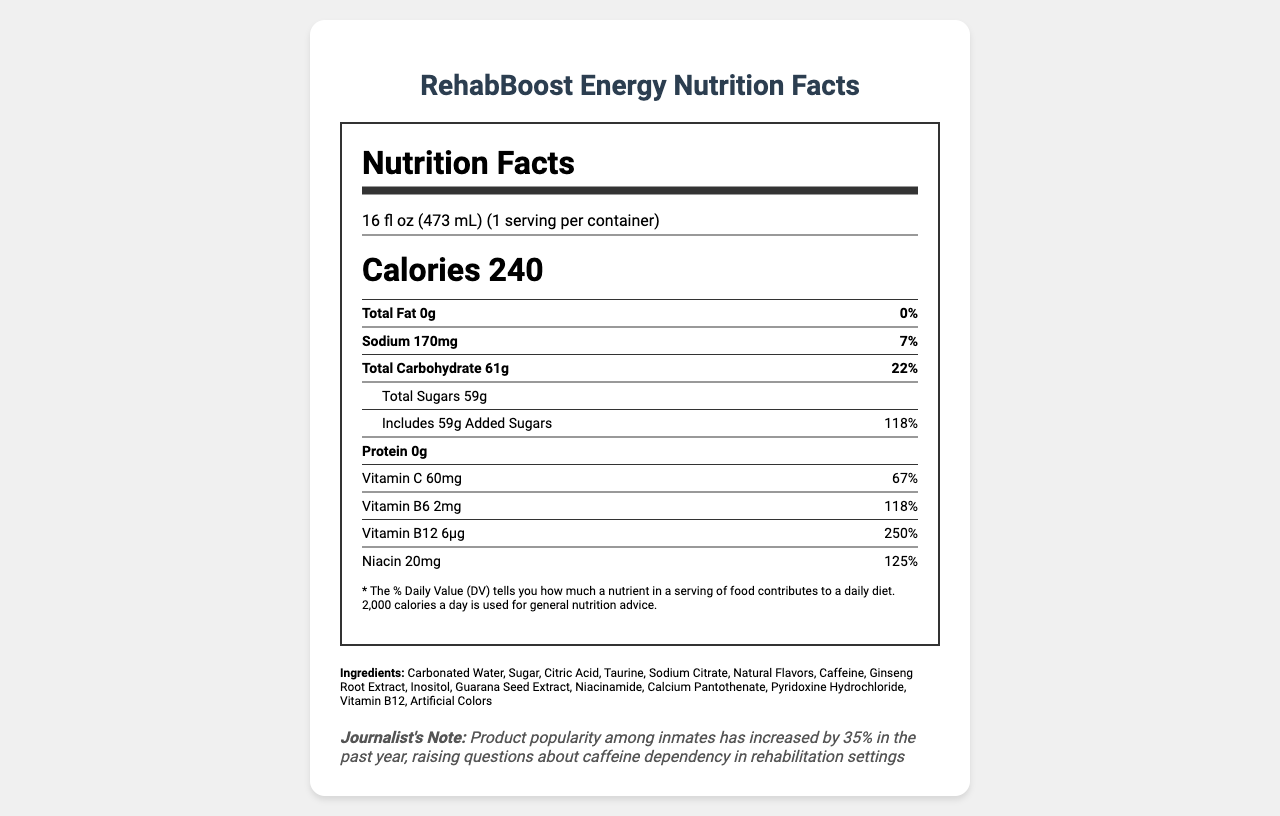what is the serving size of RehabBoost Energy? The serving size is clearly mentioned at the beginning of the document as "16 fl oz (473 mL)".
Answer: 16 fl oz (473 mL) how many calories are in one serving of RehabBoost Energy? The document states the calorie content in the large text under the serving information as "Calories 240".
Answer: 240 calories which ingredient contributes the highest percentage of daily value? A. Sodium B. Added Sugars C. Vitamin B12 D. Niacin Vitamin B12 contributes 250% daily value, which is higher than any other listed percentages.
Answer: C how much caffeine is present in RehabBoost Energy? The amount of caffeine is listed under the additional ingredients section as "Caffeine 200mg".
Answer: 200 mg true or false: RehabBoost Energy contains protein. The document states the protein content as "0g," indicating no protein.
Answer: False how much sodium does one serving of RehabBoost Energy contain? The amount of sodium is listed as "Sodium 170mg".
Answer: 170 mg what should be monitored by the rehabilitation staff according to the document? The document states under “rehabilitation note” that consumption should be monitored by rehabilitation staff.
Answer: Consumption of RehabBoost Energy which vitamins are included in RehabBoost Energy? The document lists these vitamins specifically with their respective values.
Answer: Vitamin C, Vitamin B6, Vitamin B12, Niacin what is the warning provided with RehabBoost Energy? The warning is explicitly mentioned at the end of the document.
Answer: Not recommended for children, pregnant women, or persons sensitive to caffeine. Do not mix with alcohol. what is the primary sweetener used in RehabBoost Energy? A. Aspartame B. Sugar C. High Fructose Corn Syrup D. Sucralose The ingredients list includes 'Sugar,' making it the primary sweetener.
Answer: B what additional note is provided for journalists regarding Rehabilitation Boost Energy? The journalist note section mentions this increase in popularity and the potential issue with caffeine dependency.
Answer: Product popularity among inmates has increased by 35% in the past year, raising questions about caffeine dependency in rehabilitation settings how much niacin is present in RehabBoost Energy? The amount of niacin is listed as "Niacin 20mg".
Answer: 20 mg why is the product exclusively available through approved rehabilitation program vendors? The document notes in the distribution section that it is part of a controlled nutrition program.
Answer: Part of controlled nutrition program what is the main idea of the document? The document summarizes the key nutritional facts, ingredients, manufacturer information, warnings, and notes for monitoring in rehabilitation settings.
Answer: The document provides detailed nutritional information about RehabBoost Energy and is intended for use within controlled rehabilitation settings. It highlights nutritional content, ingredients, warnings, and notes on monitoring usage within rehabilitation programs. cannot be determined: How many units of RehabBoost Energy were sold last year? The document does not provide any sales data or information on the number of units sold.
Answer: Cannot be determined 